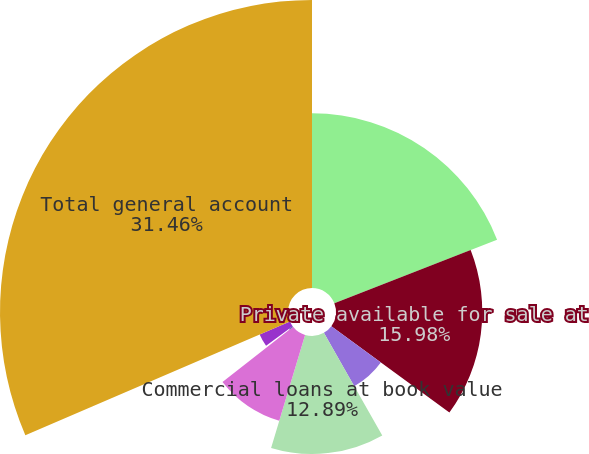<chart> <loc_0><loc_0><loc_500><loc_500><pie_chart><fcel>Public available for sale at<fcel>Private available for sale at<fcel>Equity securities available<fcel>Commercial loans at book value<fcel>Policy loans at outstanding<fcel>Other long-term investments(1)<fcel>Short-term investments(2)<fcel>Total general account<nl><fcel>19.08%<fcel>15.98%<fcel>6.7%<fcel>12.89%<fcel>9.79%<fcel>0.5%<fcel>3.6%<fcel>31.46%<nl></chart> 